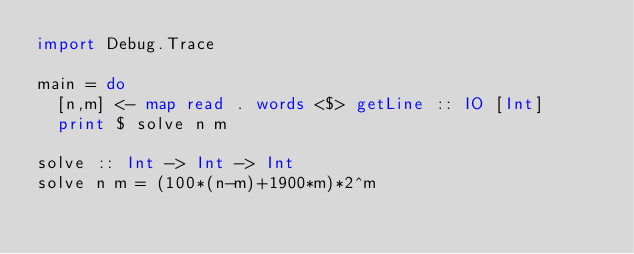<code> <loc_0><loc_0><loc_500><loc_500><_Haskell_>import Debug.Trace

main = do
  [n,m] <- map read . words <$> getLine :: IO [Int]
  print $ solve n m

solve :: Int -> Int -> Int
solve n m = (100*(n-m)+1900*m)*2^m
</code> 